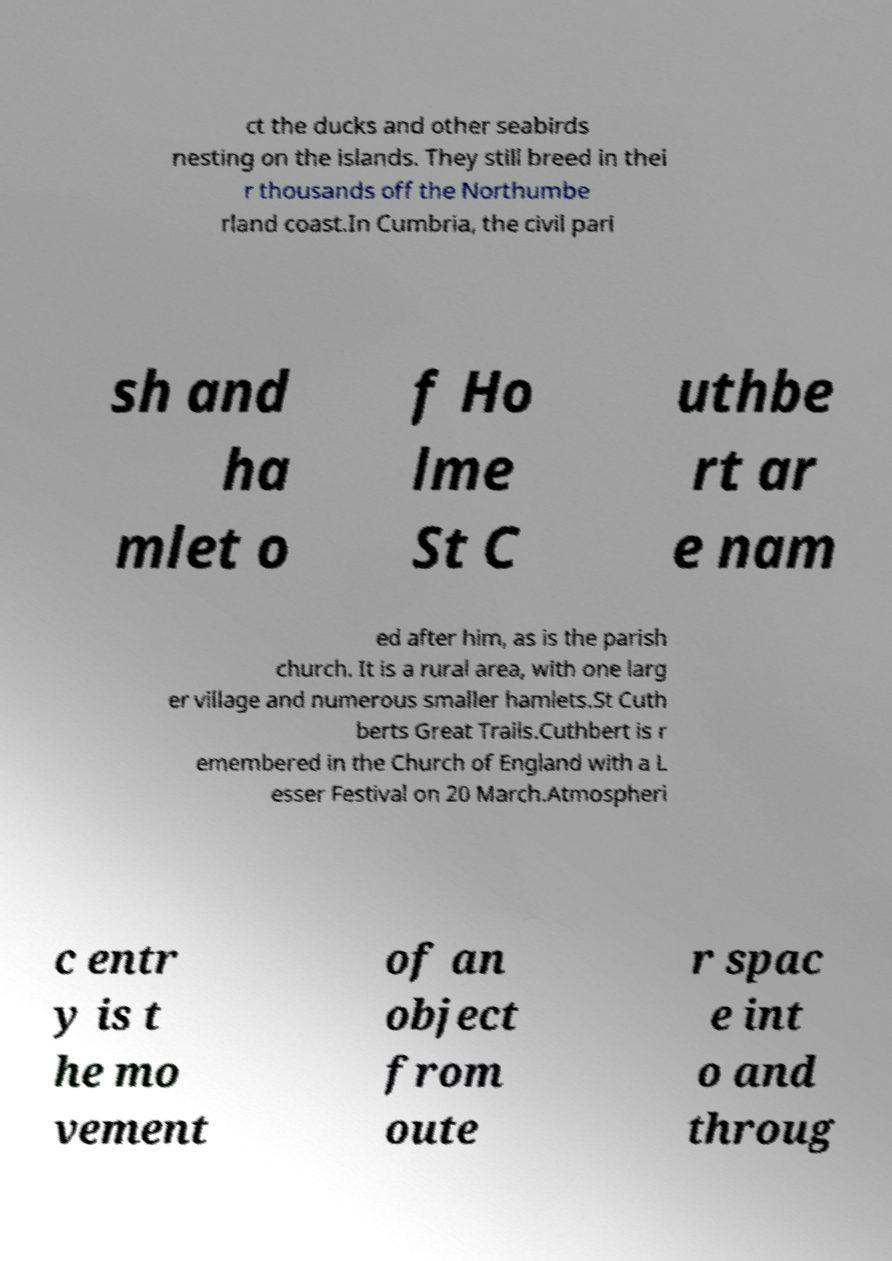For documentation purposes, I need the text within this image transcribed. Could you provide that? ct the ducks and other seabirds nesting on the islands. They still breed in thei r thousands off the Northumbe rland coast.In Cumbria, the civil pari sh and ha mlet o f Ho lme St C uthbe rt ar e nam ed after him, as is the parish church. It is a rural area, with one larg er village and numerous smaller hamlets.St Cuth berts Great Trails.Cuthbert is r emembered in the Church of England with a L esser Festival on 20 March.Atmospheri c entr y is t he mo vement of an object from oute r spac e int o and throug 